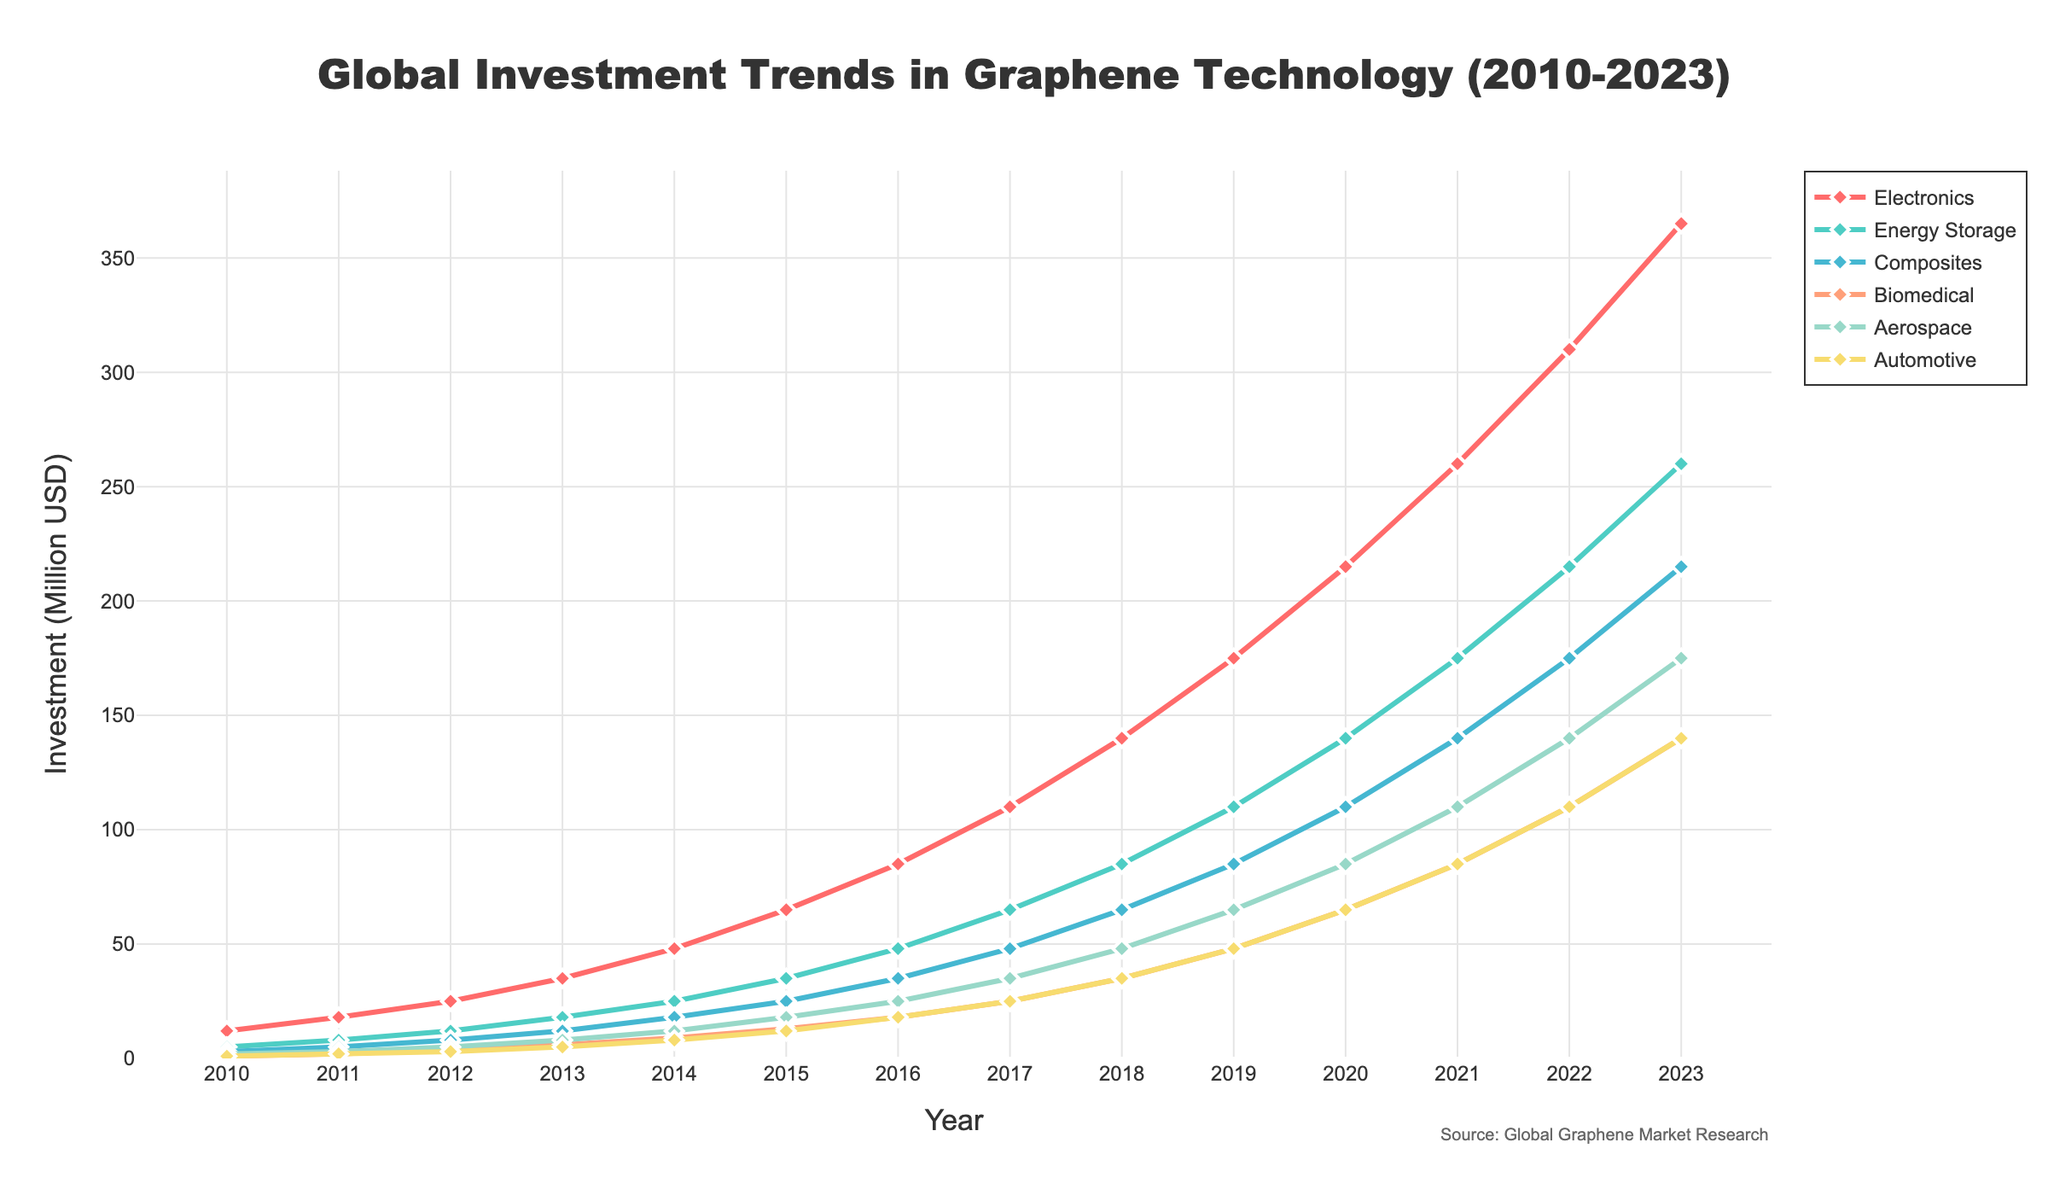What was the total global investment in graphene technology across all industries in 2015? To find the total investment in 2015, sum up the investment values across all industries: 65 (Electronics) + 35 (Energy Storage) + 25 (Composites) + 13 (Biomedical) + 18 (Aerospace) + 12 (Automotive) = 168 million USD.
Answer: 168 million USD Which industry saw the highest investment in 2018? By examining the figure for 2018, the industry with the highest investment can be identified as Electronics, with a value of 140 million USD.
Answer: Electronics How does the investment trend for Biomedical compare to that of Aerospace from 2010 to 2023? For Biomedical, the investment starts at 1 million USD in 2010 and rises to 140 million USD in 2023. For Aerospace, the investment starts at 2 million USD in 2010 and rises to 175 million USD in 2023. Both industries show increasing trends, but Aerospace shows a higher overall increase.
Answer: Aerospace shows higher overall increase What is the difference in investment between Electronics and Automotive in 2020? In 2020, Electronics has 215 million USD, and Automotive has 65 million USD. The difference is 215 - 65 = 150 million USD.
Answer: 150 million USD How much did the investment in Energy Storage increase from 2010 to 2023? In 2010, Energy Storage investment was 5 million USD, and by 2023, it reached 260 million USD. The increase is 260 - 5 = 255 million USD.
Answer: 255 million USD Identify the year when the Aerospace industry's investment reached the 100 million USD mark. By analyzing the figure, it can be observed that the Aerospace industry reached 100 million USD in 2020.
Answer: 2020 Compare the investment growth rate of Electronics and Composites between 2012 and 2016. For Electronics, the investment grows from 25 million USD in 2012 to 85 million USD in 2016, an increase of 60 million USD. For Composites, the investment grows from 8 million USD in 2012 to 35 million USD in 2016, an increase of 27 million USD. The Electronics industry shows a higher growth rate.
Answer: Electronics shows higher growth rate What is the average annual investment in the Automotive industry from 2010 to 2023? Sum up the annual investments from 2010 to 2023: 1 + 2 + 3 + 5 + 8 + 12 + 18 + 25 + 35 + 48 + 65 + 85 + 110 + 140 = 557 million USD. There are 14 years, so the average is 557 / 14 = 39.79 million USD.
Answer: 39.79 million USD 